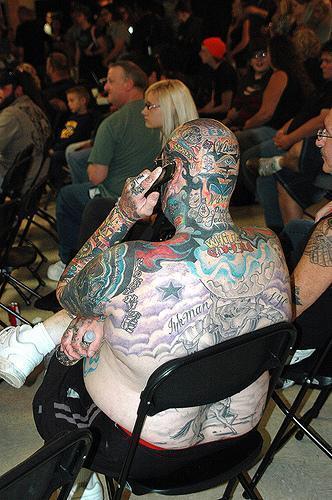How many phones are pictured?
Give a very brief answer. 1. 